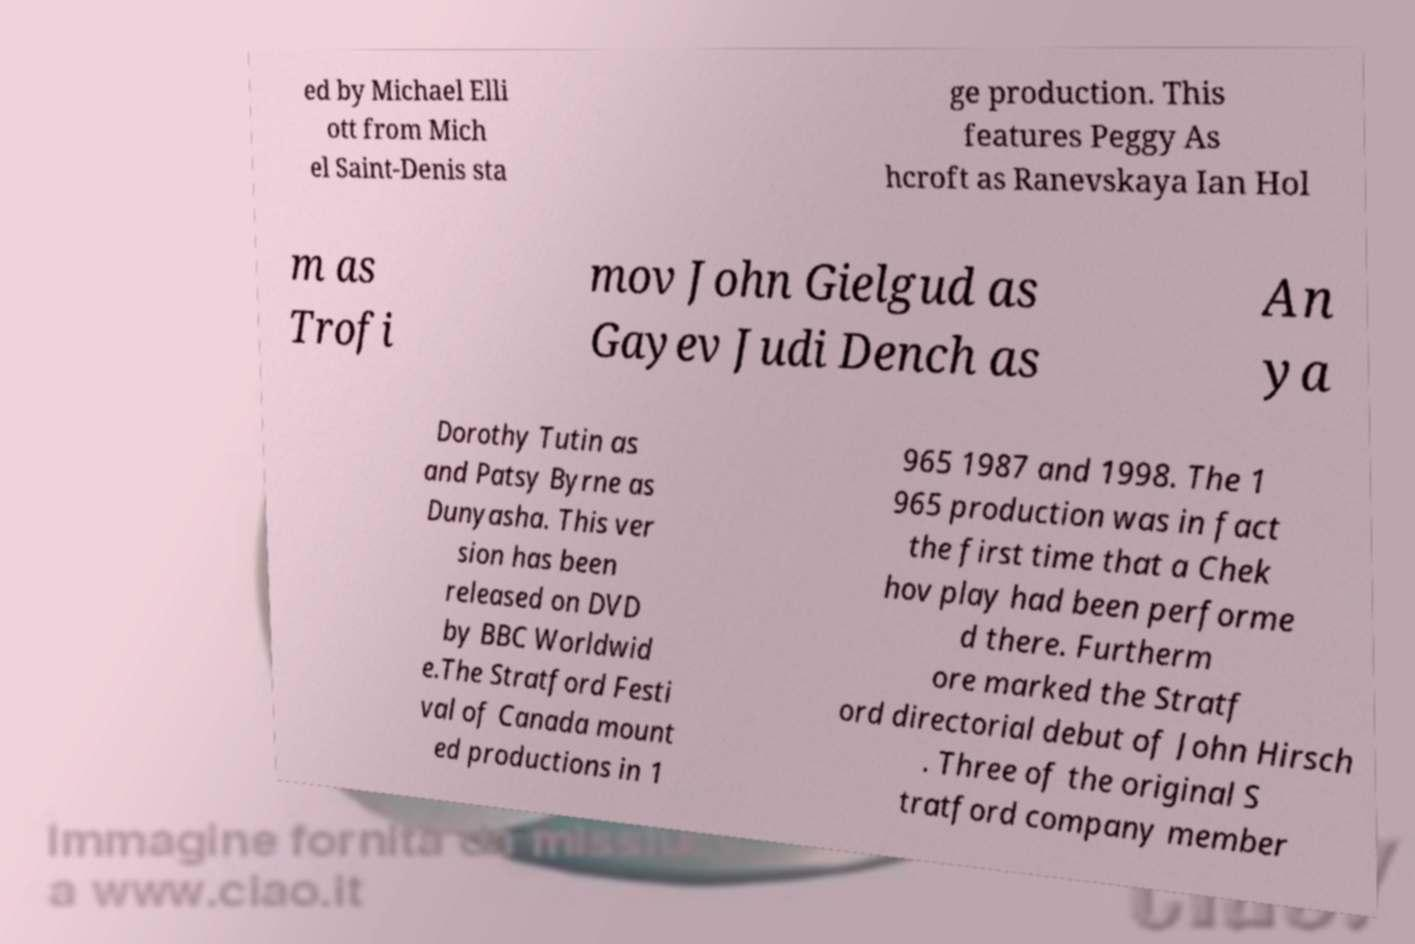Could you assist in decoding the text presented in this image and type it out clearly? ed by Michael Elli ott from Mich el Saint-Denis sta ge production. This features Peggy As hcroft as Ranevskaya Ian Hol m as Trofi mov John Gielgud as Gayev Judi Dench as An ya Dorothy Tutin as and Patsy Byrne as Dunyasha. This ver sion has been released on DVD by BBC Worldwid e.The Stratford Festi val of Canada mount ed productions in 1 965 1987 and 1998. The 1 965 production was in fact the first time that a Chek hov play had been performe d there. Furtherm ore marked the Stratf ord directorial debut of John Hirsch . Three of the original S tratford company member 